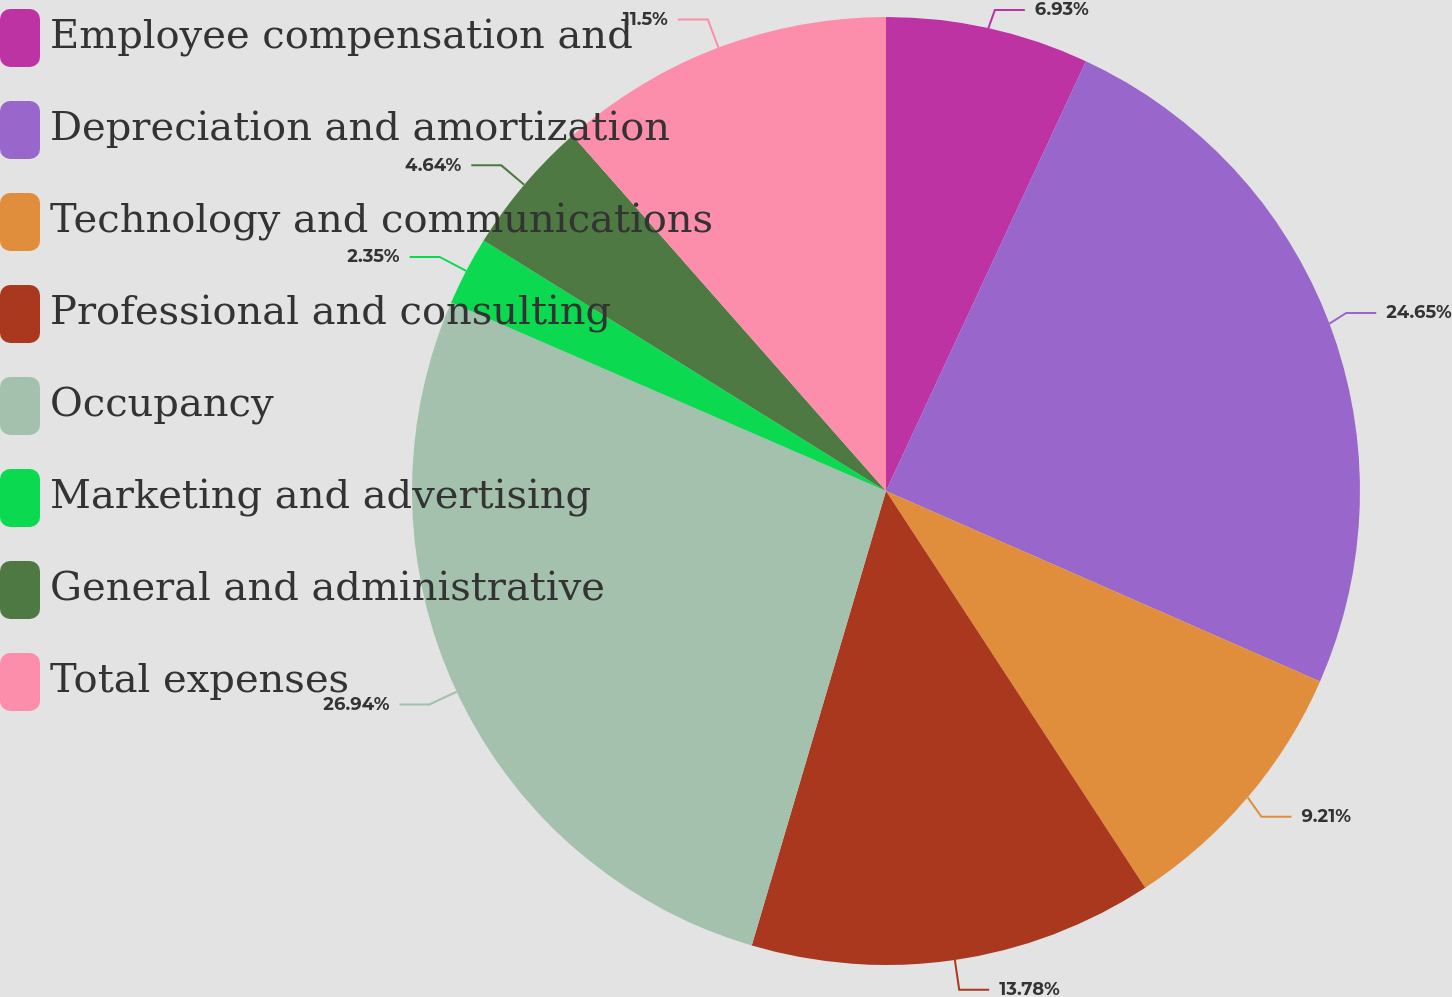<chart> <loc_0><loc_0><loc_500><loc_500><pie_chart><fcel>Employee compensation and<fcel>Depreciation and amortization<fcel>Technology and communications<fcel>Professional and consulting<fcel>Occupancy<fcel>Marketing and advertising<fcel>General and administrative<fcel>Total expenses<nl><fcel>6.93%<fcel>24.65%<fcel>9.21%<fcel>13.78%<fcel>26.94%<fcel>2.35%<fcel>4.64%<fcel>11.5%<nl></chart> 